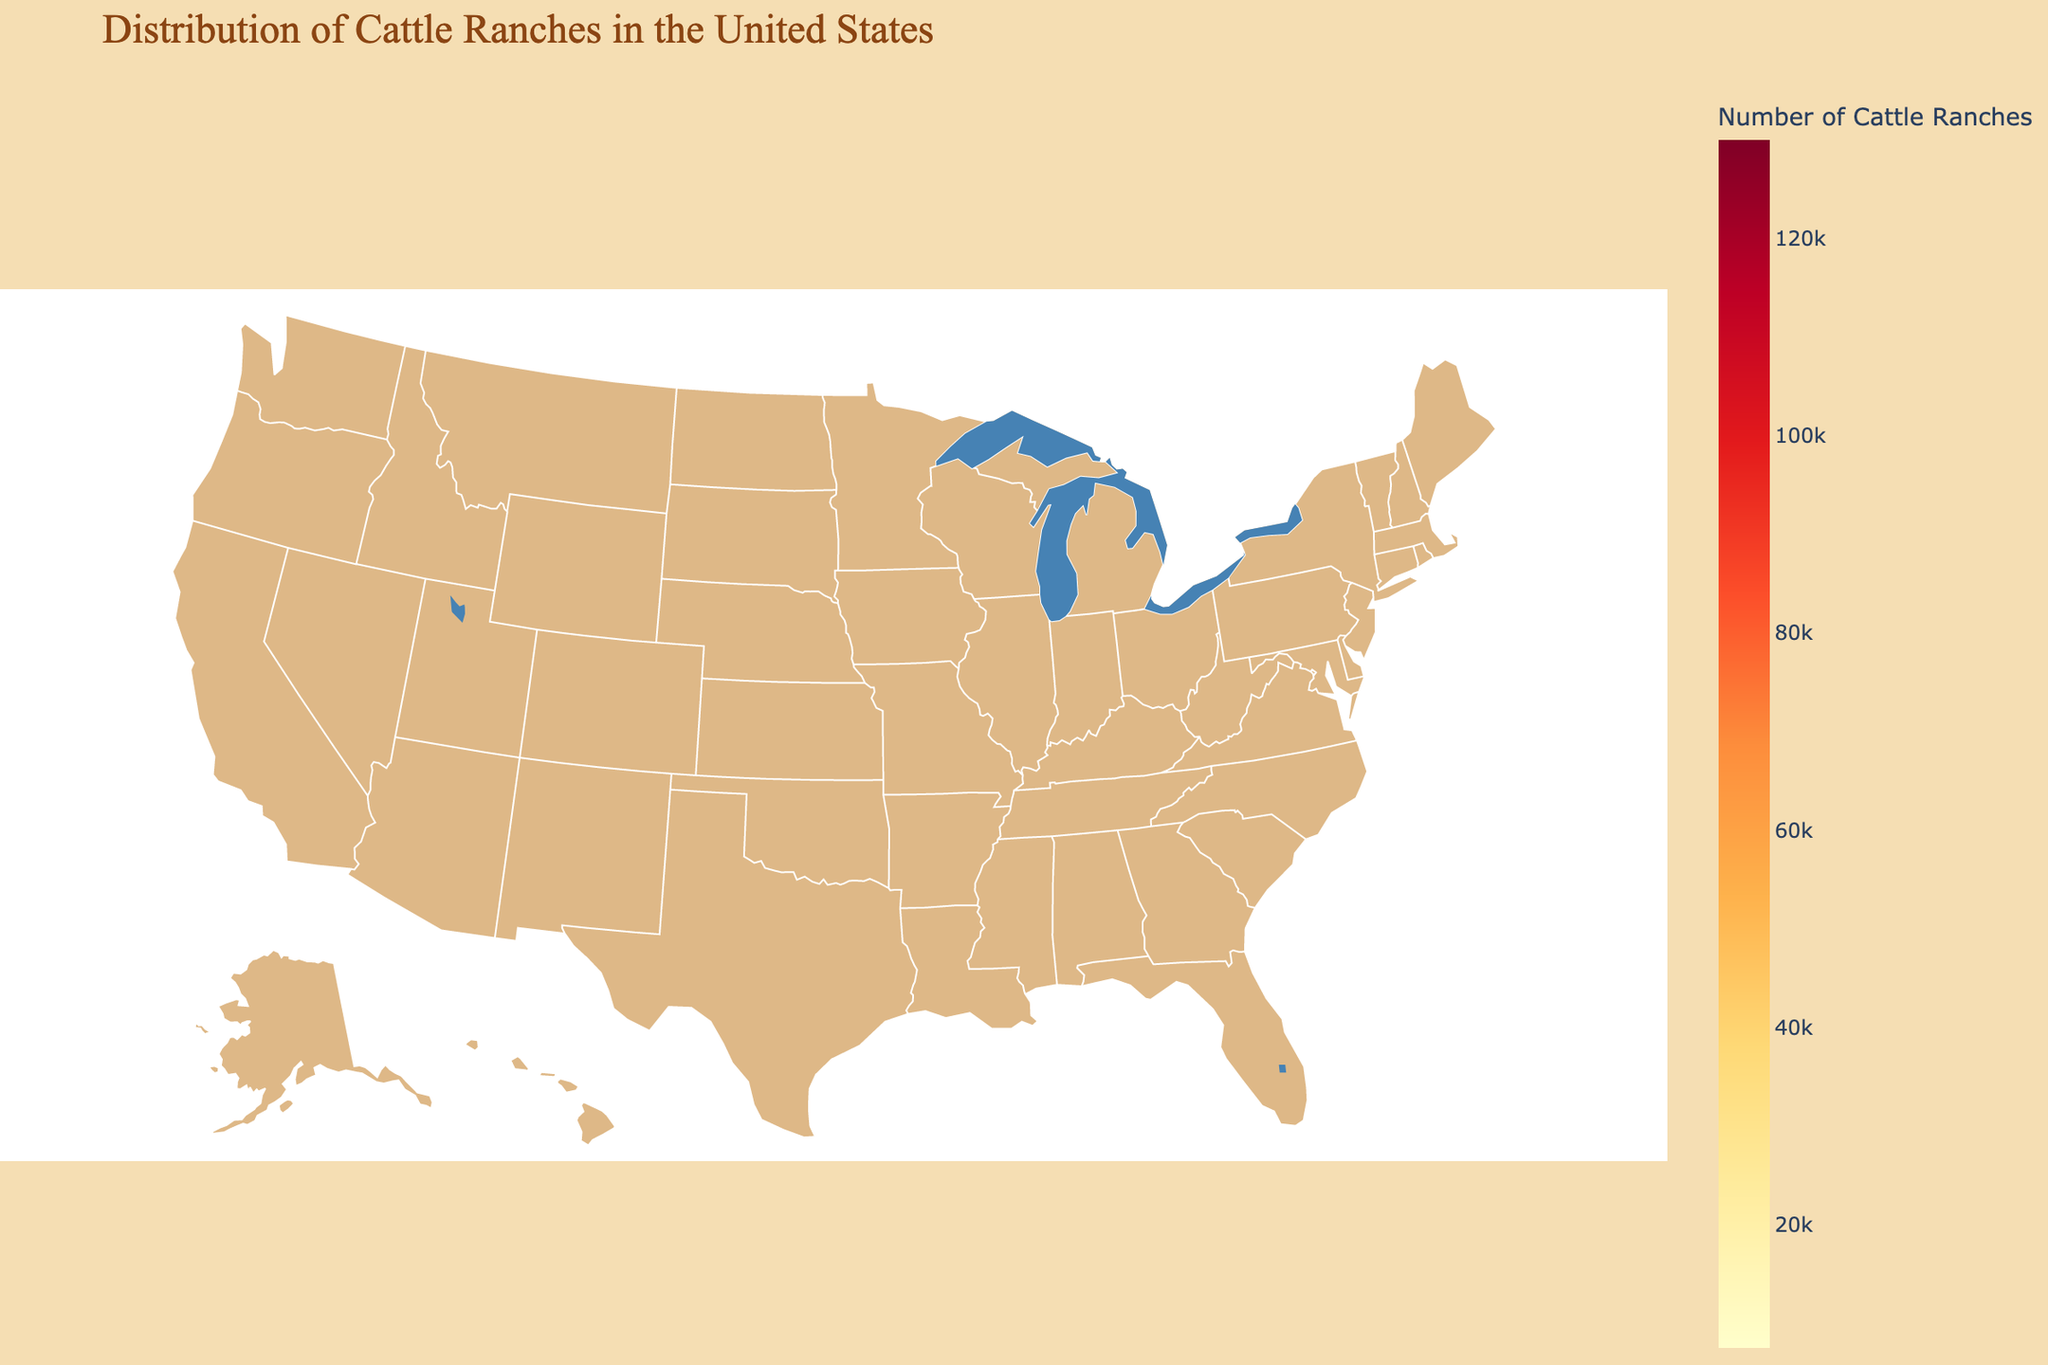Which state has the highest number of cattle ranches? The figure shows different states with the number of cattle ranches highlighted. The state with the highest concentration of color corresponding to the highest number is Texas.
Answer: Texas Which state has the lowest number of cattle ranches? By observing the states with the lightest color on the choropleth, which indicates fewer cattle ranches, Idaho has the lowest number with only 8,000 ranches.
Answer: Idaho What's the total number of cattle ranches in Texas, Oklahoma, and Missouri combined? Sum the number of cattle ranches in Texas (130,000), Oklahoma (51,000), and Missouri (50,000). The total is 130,000 + 51,000 + 50,000 = 231,000.
Answer: 231,000 What is the cultural tradition score of the state with the second highest number of cattle ranches? The second highest number of cattle ranches is in Oklahoma with 51,000 ranches. The cultural tradition score for Oklahoma is 9.0.
Answer: 9.0 Which state has a higher cultural tradition score, Kansas or North Dakota? Compare the cultural tradition scores shown for Kansas (8.5) and North Dakota (8.8). North Dakota has a higher score.
Answer: North Dakota How many states have more than 20,000 cattle ranches? From the data: Texas, Nebraska, Kansas, Oklahoma, Missouri, and Iowa each have more than 20,000 cattle ranches. Count these states: Texas, Nebraska, Kansas, Oklahoma, Missouri, Iowa = 6 states.
Answer: 6 What's the average number of cattle ranches in the states with a cultural tradition score greater than 8.5? Identify states with scores above 8.5: Texas (9.2), Oklahoma (9.0), Montana (8.9), North Dakota (8.8), Nebraska (8.7). Sum their ranches and divide by the number of states: (130,000 + 51,000 + 11,000 + 9,500 + 20,000) / 5 = 44,500.
Answer: 44,500 Which two states with more than 30,000 cattle ranches have the smallest difference in cultural tradition scores? Identify states with more than 30,000 cattle ranches: Texas, Oklahoma, Missouri. Compare scores: Oklahoma (9.0) and Missouri (8.3) have the smallest difference of 0.7.
Answer: Oklahoma and Missouri Which state has fewer cattle ranches, Montana or Oregon, and by how many? Montana has 11,000 cattle ranches, while Oregon has 12,000. The difference is 12,000 - 11,000 = 1,000 cattle ranches.
Answer: Montana by 1,000 Are there any western states with fewer than 10,000 cattle ranches? Identify western states and their number of cattle ranches. Wyoming (9,000), Idaho (8,000), New Mexico (7,500) all have fewer than 10,000 cattle ranches.
Answer: Yes 